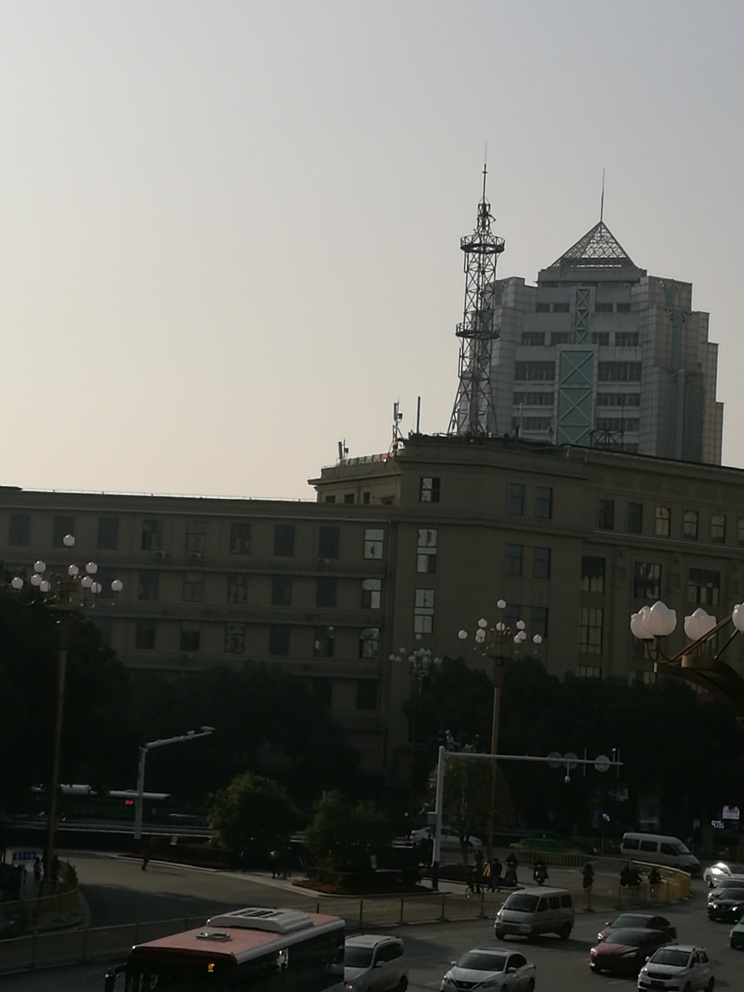What might the weather conditions be based on the photo's lighting? The lighting in the photo suggests that it could be either a cloudy day or the image was taken during the early morning or late afternoon hours when the sun is not at its peak brightness. The lack of harsh shadows and the even distribution of light across the scene indicate an overcast sky, which has resulted in a somewhat flat lighting condition throughout the image. This provides enough visibility to discern details without the contrast that would be present on a sunny day with clear skies. 